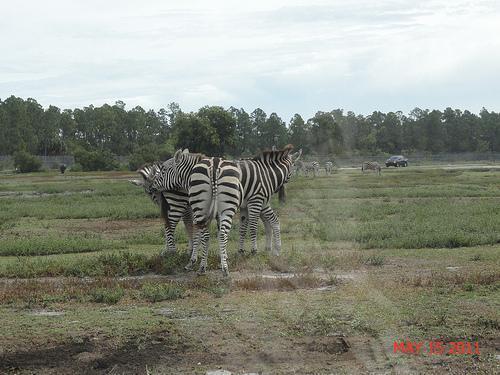How many animals are in the front?
Give a very brief answer. 2. How many animals are there?
Give a very brief answer. 5. 